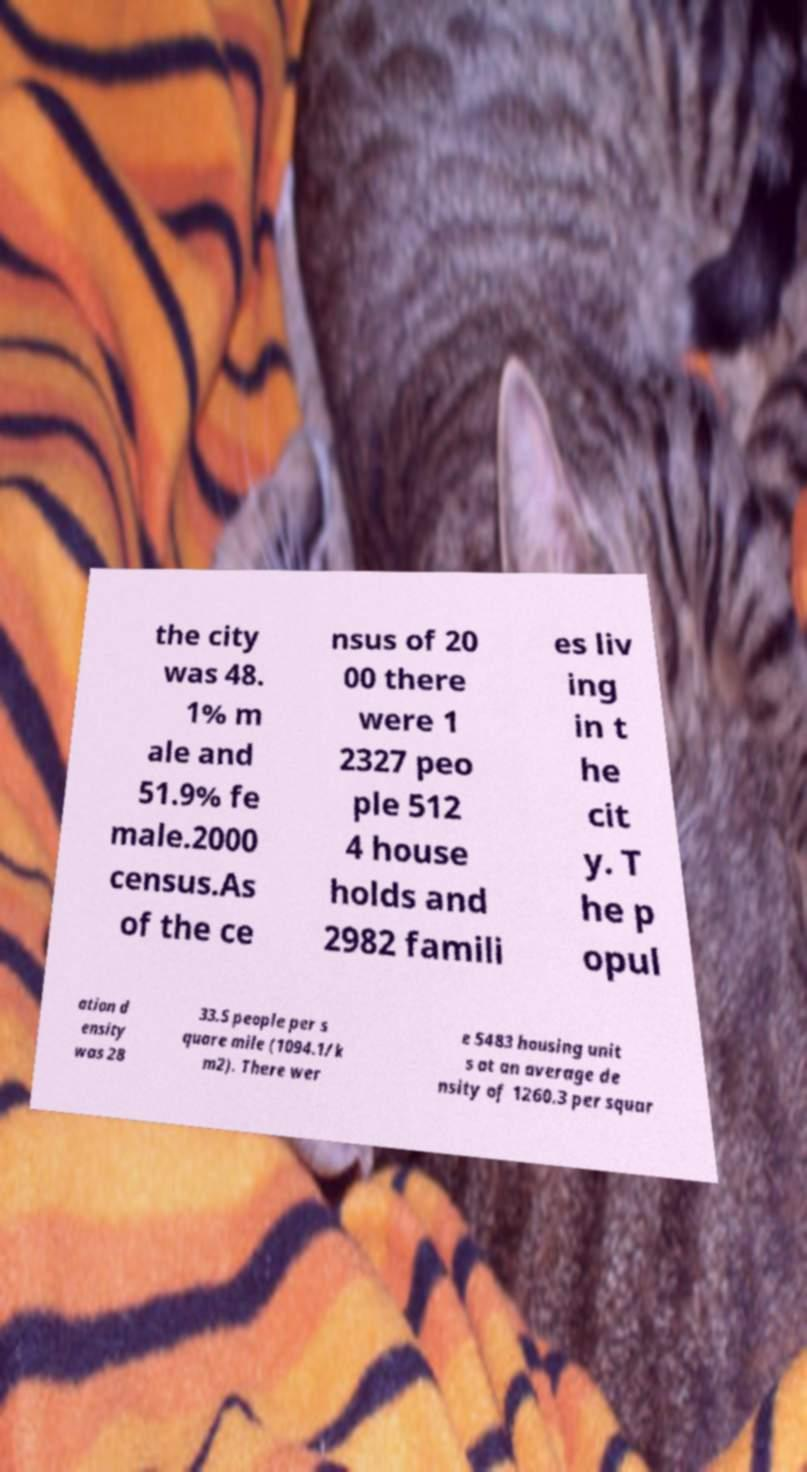Please read and relay the text visible in this image. What does it say? the city was 48. 1% m ale and 51.9% fe male.2000 census.As of the ce nsus of 20 00 there were 1 2327 peo ple 512 4 house holds and 2982 famili es liv ing in t he cit y. T he p opul ation d ensity was 28 33.5 people per s quare mile (1094.1/k m2). There wer e 5483 housing unit s at an average de nsity of 1260.3 per squar 